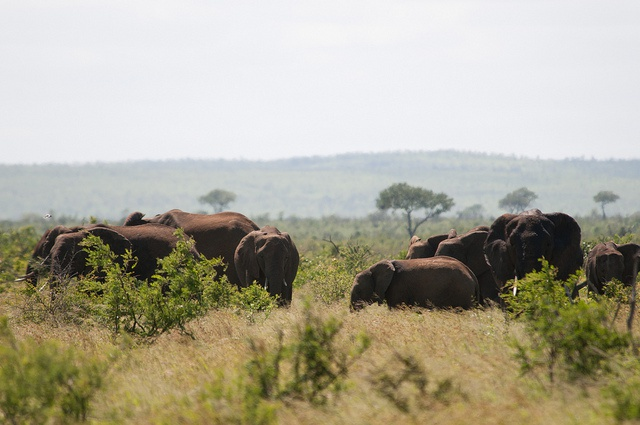Describe the objects in this image and their specific colors. I can see elephant in white, black, olive, and gray tones, elephant in white, black, gray, and olive tones, elephant in white, black, and gray tones, elephant in white, black, gray, and olive tones, and elephant in white, black, gray, and tan tones in this image. 